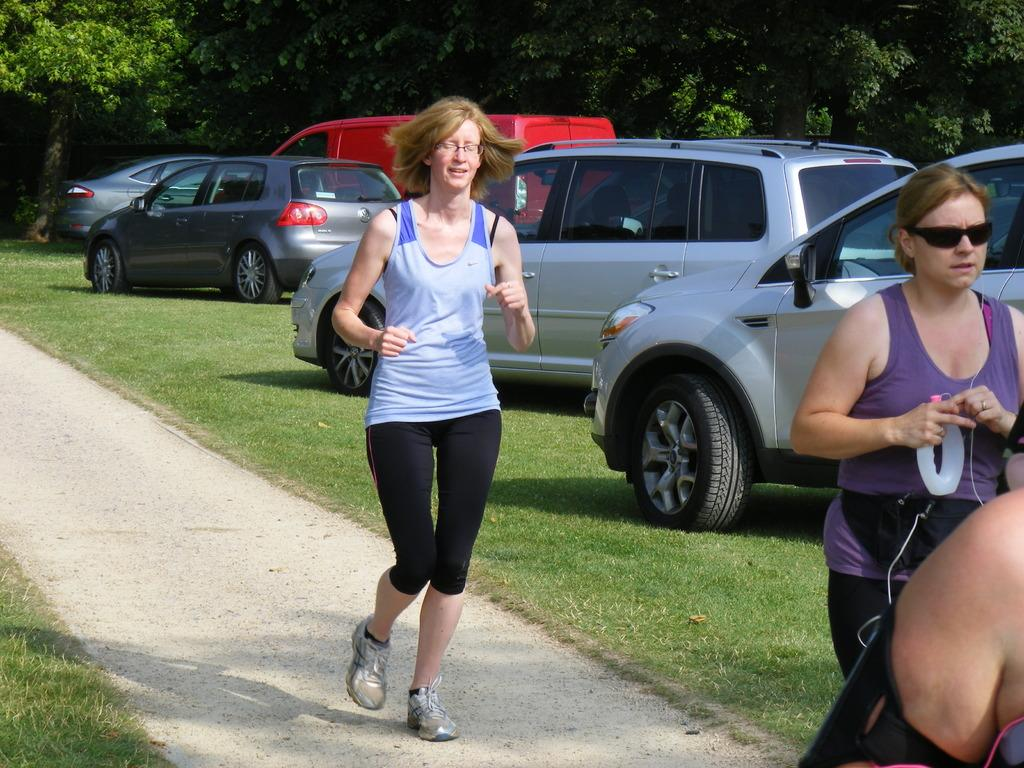Who or what can be seen in the image? There are people in the image. What else is present in the image besides people? There are vehicles and trees in the image. What is the surface that the people and vehicles are on? The ground is visible in the image. What type of vegetation is present on the ground? There is grass on the ground. What hobbies do the nails in the image have? There are no nails present in the image, so it is not possible to determine their hobbies. 